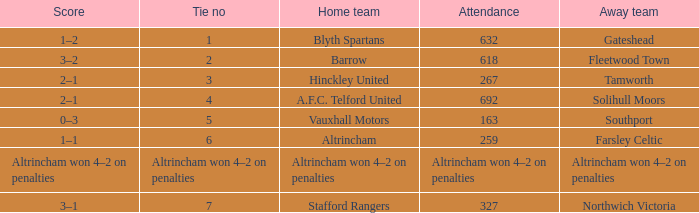What was the score when there were 7 ties? 3–1. Can you give me this table as a dict? {'header': ['Score', 'Tie no', 'Home team', 'Attendance', 'Away team'], 'rows': [['1–2', '1', 'Blyth Spartans', '632', 'Gateshead'], ['3–2', '2', 'Barrow', '618', 'Fleetwood Town'], ['2–1', '3', 'Hinckley United', '267', 'Tamworth'], ['2–1', '4', 'A.F.C. Telford United', '692', 'Solihull Moors'], ['0–3', '5', 'Vauxhall Motors', '163', 'Southport'], ['1–1', '6', 'Altrincham', '259', 'Farsley Celtic'], ['Altrincham won 4–2 on penalties', 'Altrincham won 4–2 on penalties', 'Altrincham won 4–2 on penalties', 'Altrincham won 4–2 on penalties', 'Altrincham won 4–2 on penalties'], ['3–1', '7', 'Stafford Rangers', '327', 'Northwich Victoria']]} 